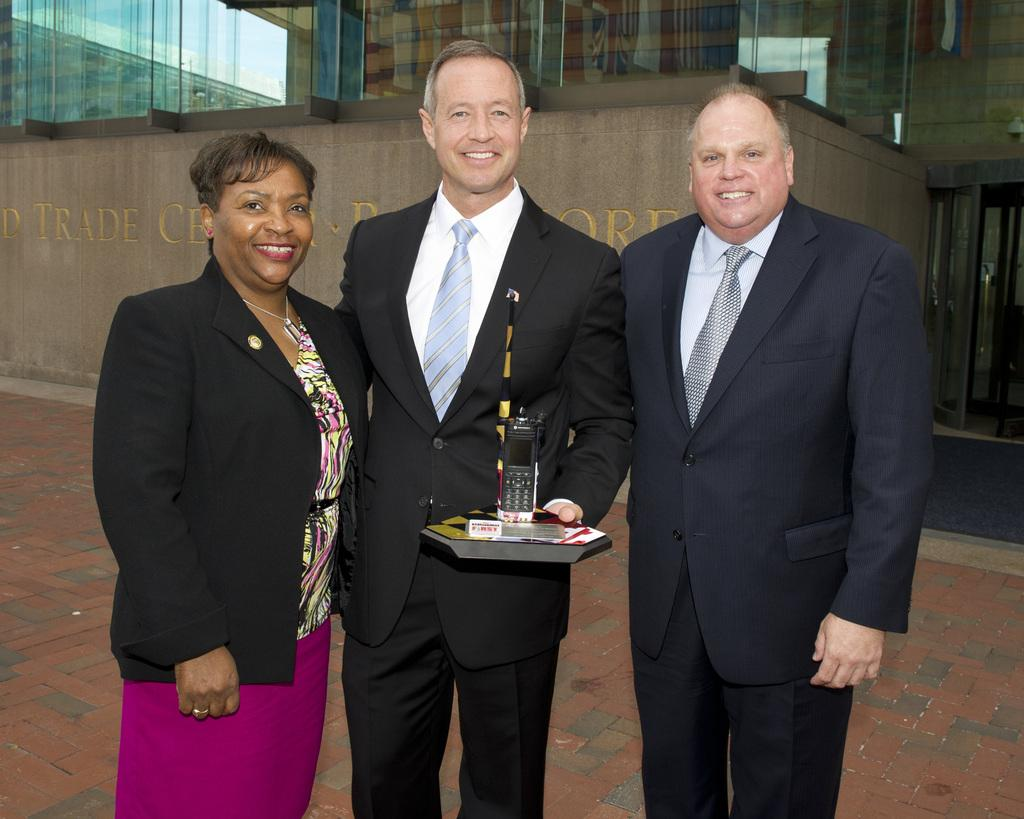How many people are in the image? There are three persons standing in the center of the image. What can be seen in the background of the image? There is a wall in the background of the image. Is there any blood visible on the persons or the wall in the image? No, there is no blood visible on the persons or the wall in the image. 